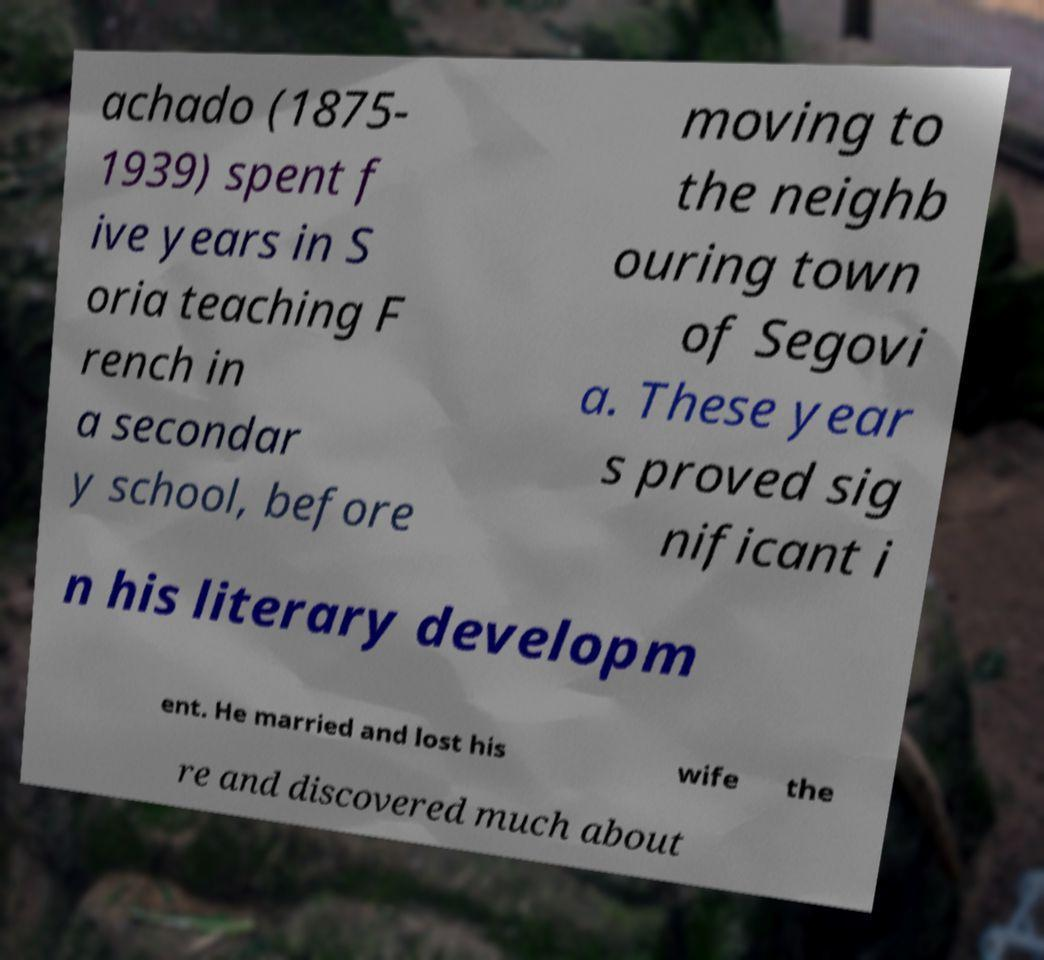Please read and relay the text visible in this image. What does it say? achado (1875- 1939) spent f ive years in S oria teaching F rench in a secondar y school, before moving to the neighb ouring town of Segovi a. These year s proved sig nificant i n his literary developm ent. He married and lost his wife the re and discovered much about 